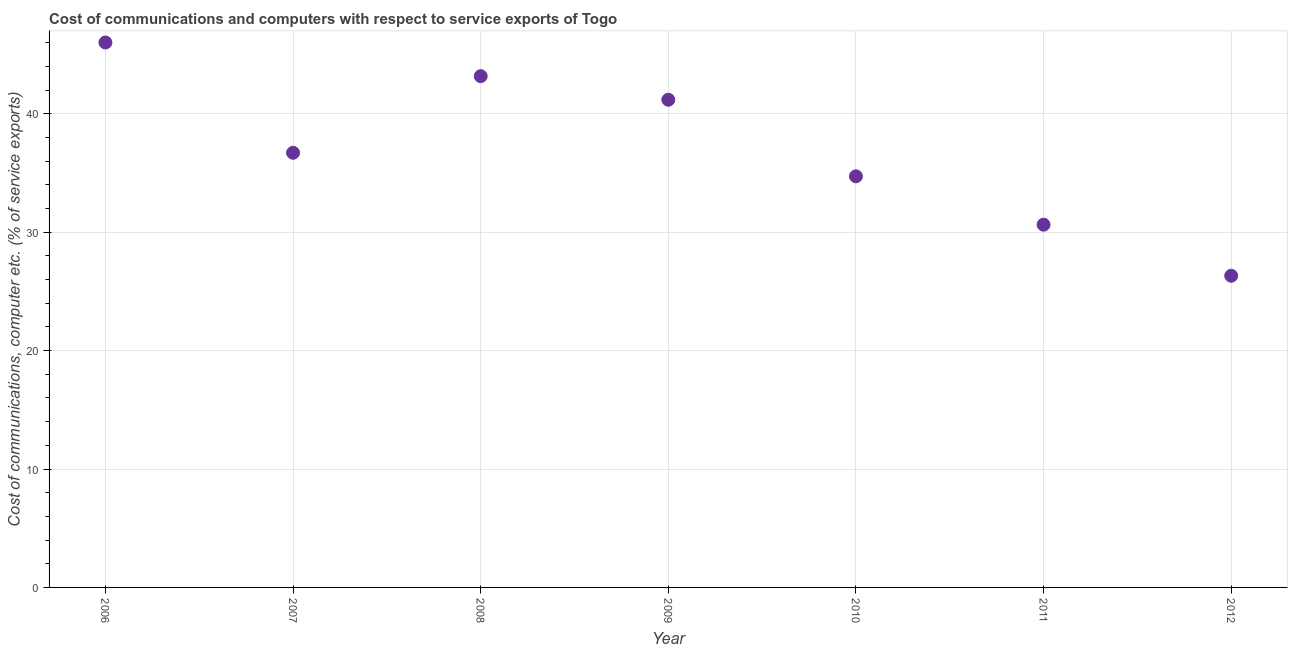What is the cost of communications and computer in 2011?
Provide a succinct answer. 30.64. Across all years, what is the maximum cost of communications and computer?
Your response must be concise. 46.03. Across all years, what is the minimum cost of communications and computer?
Provide a short and direct response. 26.33. In which year was the cost of communications and computer maximum?
Keep it short and to the point. 2006. In which year was the cost of communications and computer minimum?
Your response must be concise. 2012. What is the sum of the cost of communications and computer?
Your answer should be very brief. 258.8. What is the difference between the cost of communications and computer in 2011 and 2012?
Provide a succinct answer. 4.31. What is the average cost of communications and computer per year?
Offer a very short reply. 36.97. What is the median cost of communications and computer?
Give a very brief answer. 36.71. What is the ratio of the cost of communications and computer in 2009 to that in 2012?
Give a very brief answer. 1.56. What is the difference between the highest and the second highest cost of communications and computer?
Keep it short and to the point. 2.84. Is the sum of the cost of communications and computer in 2008 and 2009 greater than the maximum cost of communications and computer across all years?
Offer a very short reply. Yes. What is the difference between the highest and the lowest cost of communications and computer?
Your response must be concise. 19.7. Does the cost of communications and computer monotonically increase over the years?
Ensure brevity in your answer.  No. How many dotlines are there?
Provide a short and direct response. 1. What is the difference between two consecutive major ticks on the Y-axis?
Offer a very short reply. 10. Are the values on the major ticks of Y-axis written in scientific E-notation?
Offer a terse response. No. What is the title of the graph?
Offer a very short reply. Cost of communications and computers with respect to service exports of Togo. What is the label or title of the X-axis?
Provide a succinct answer. Year. What is the label or title of the Y-axis?
Your response must be concise. Cost of communications, computer etc. (% of service exports). What is the Cost of communications, computer etc. (% of service exports) in 2006?
Your answer should be very brief. 46.03. What is the Cost of communications, computer etc. (% of service exports) in 2007?
Make the answer very short. 36.71. What is the Cost of communications, computer etc. (% of service exports) in 2008?
Ensure brevity in your answer.  43.18. What is the Cost of communications, computer etc. (% of service exports) in 2009?
Give a very brief answer. 41.19. What is the Cost of communications, computer etc. (% of service exports) in 2010?
Offer a terse response. 34.72. What is the Cost of communications, computer etc. (% of service exports) in 2011?
Keep it short and to the point. 30.64. What is the Cost of communications, computer etc. (% of service exports) in 2012?
Offer a very short reply. 26.33. What is the difference between the Cost of communications, computer etc. (% of service exports) in 2006 and 2007?
Your response must be concise. 9.32. What is the difference between the Cost of communications, computer etc. (% of service exports) in 2006 and 2008?
Offer a terse response. 2.84. What is the difference between the Cost of communications, computer etc. (% of service exports) in 2006 and 2009?
Your answer should be very brief. 4.84. What is the difference between the Cost of communications, computer etc. (% of service exports) in 2006 and 2010?
Keep it short and to the point. 11.3. What is the difference between the Cost of communications, computer etc. (% of service exports) in 2006 and 2011?
Your response must be concise. 15.39. What is the difference between the Cost of communications, computer etc. (% of service exports) in 2006 and 2012?
Ensure brevity in your answer.  19.7. What is the difference between the Cost of communications, computer etc. (% of service exports) in 2007 and 2008?
Make the answer very short. -6.47. What is the difference between the Cost of communications, computer etc. (% of service exports) in 2007 and 2009?
Provide a short and direct response. -4.48. What is the difference between the Cost of communications, computer etc. (% of service exports) in 2007 and 2010?
Offer a terse response. 1.99. What is the difference between the Cost of communications, computer etc. (% of service exports) in 2007 and 2011?
Offer a very short reply. 6.07. What is the difference between the Cost of communications, computer etc. (% of service exports) in 2007 and 2012?
Keep it short and to the point. 10.39. What is the difference between the Cost of communications, computer etc. (% of service exports) in 2008 and 2009?
Provide a short and direct response. 1.99. What is the difference between the Cost of communications, computer etc. (% of service exports) in 2008 and 2010?
Your answer should be very brief. 8.46. What is the difference between the Cost of communications, computer etc. (% of service exports) in 2008 and 2011?
Your answer should be compact. 12.54. What is the difference between the Cost of communications, computer etc. (% of service exports) in 2008 and 2012?
Keep it short and to the point. 16.86. What is the difference between the Cost of communications, computer etc. (% of service exports) in 2009 and 2010?
Keep it short and to the point. 6.47. What is the difference between the Cost of communications, computer etc. (% of service exports) in 2009 and 2011?
Ensure brevity in your answer.  10.55. What is the difference between the Cost of communications, computer etc. (% of service exports) in 2009 and 2012?
Offer a very short reply. 14.87. What is the difference between the Cost of communications, computer etc. (% of service exports) in 2010 and 2011?
Your answer should be very brief. 4.09. What is the difference between the Cost of communications, computer etc. (% of service exports) in 2010 and 2012?
Your answer should be compact. 8.4. What is the difference between the Cost of communications, computer etc. (% of service exports) in 2011 and 2012?
Give a very brief answer. 4.31. What is the ratio of the Cost of communications, computer etc. (% of service exports) in 2006 to that in 2007?
Provide a short and direct response. 1.25. What is the ratio of the Cost of communications, computer etc. (% of service exports) in 2006 to that in 2008?
Give a very brief answer. 1.07. What is the ratio of the Cost of communications, computer etc. (% of service exports) in 2006 to that in 2009?
Ensure brevity in your answer.  1.12. What is the ratio of the Cost of communications, computer etc. (% of service exports) in 2006 to that in 2010?
Your response must be concise. 1.33. What is the ratio of the Cost of communications, computer etc. (% of service exports) in 2006 to that in 2011?
Your answer should be compact. 1.5. What is the ratio of the Cost of communications, computer etc. (% of service exports) in 2006 to that in 2012?
Ensure brevity in your answer.  1.75. What is the ratio of the Cost of communications, computer etc. (% of service exports) in 2007 to that in 2008?
Provide a succinct answer. 0.85. What is the ratio of the Cost of communications, computer etc. (% of service exports) in 2007 to that in 2009?
Offer a very short reply. 0.89. What is the ratio of the Cost of communications, computer etc. (% of service exports) in 2007 to that in 2010?
Your answer should be compact. 1.06. What is the ratio of the Cost of communications, computer etc. (% of service exports) in 2007 to that in 2011?
Ensure brevity in your answer.  1.2. What is the ratio of the Cost of communications, computer etc. (% of service exports) in 2007 to that in 2012?
Your response must be concise. 1.4. What is the ratio of the Cost of communications, computer etc. (% of service exports) in 2008 to that in 2009?
Offer a terse response. 1.05. What is the ratio of the Cost of communications, computer etc. (% of service exports) in 2008 to that in 2010?
Give a very brief answer. 1.24. What is the ratio of the Cost of communications, computer etc. (% of service exports) in 2008 to that in 2011?
Make the answer very short. 1.41. What is the ratio of the Cost of communications, computer etc. (% of service exports) in 2008 to that in 2012?
Give a very brief answer. 1.64. What is the ratio of the Cost of communications, computer etc. (% of service exports) in 2009 to that in 2010?
Make the answer very short. 1.19. What is the ratio of the Cost of communications, computer etc. (% of service exports) in 2009 to that in 2011?
Your answer should be very brief. 1.34. What is the ratio of the Cost of communications, computer etc. (% of service exports) in 2009 to that in 2012?
Your answer should be very brief. 1.56. What is the ratio of the Cost of communications, computer etc. (% of service exports) in 2010 to that in 2011?
Keep it short and to the point. 1.13. What is the ratio of the Cost of communications, computer etc. (% of service exports) in 2010 to that in 2012?
Provide a succinct answer. 1.32. What is the ratio of the Cost of communications, computer etc. (% of service exports) in 2011 to that in 2012?
Your response must be concise. 1.16. 